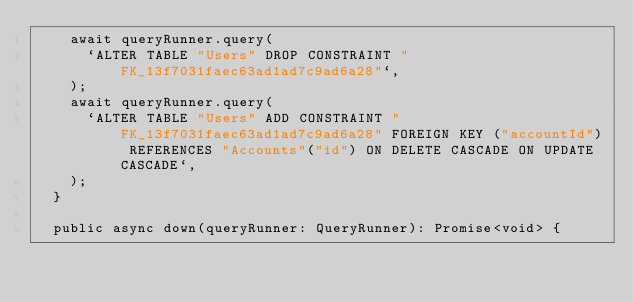Convert code to text. <code><loc_0><loc_0><loc_500><loc_500><_TypeScript_>    await queryRunner.query(
      `ALTER TABLE "Users" DROP CONSTRAINT "FK_13f7031faec63ad1ad7c9ad6a28"`,
    );
    await queryRunner.query(
      `ALTER TABLE "Users" ADD CONSTRAINT "FK_13f7031faec63ad1ad7c9ad6a28" FOREIGN KEY ("accountId") REFERENCES "Accounts"("id") ON DELETE CASCADE ON UPDATE CASCADE`,
    );
  }

  public async down(queryRunner: QueryRunner): Promise<void> {</code> 